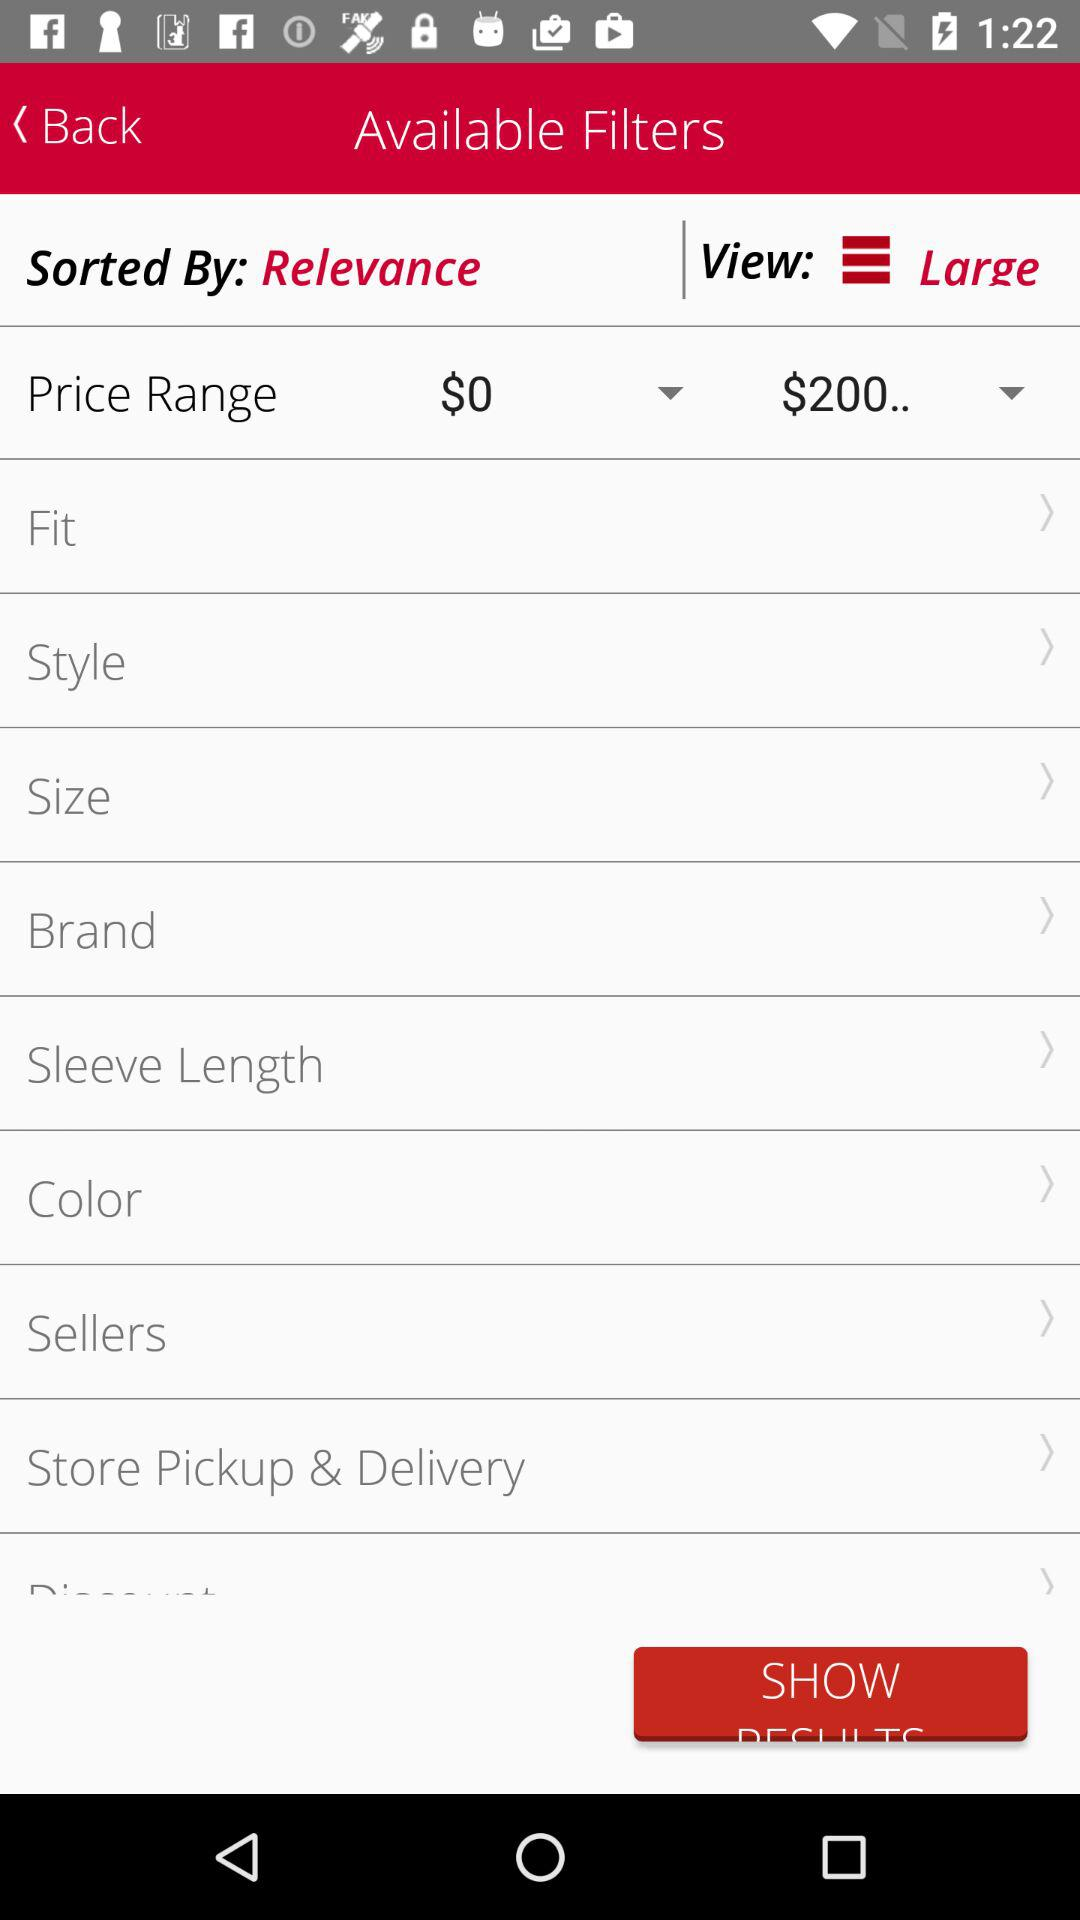How many more filters are there in the price range section than in the brand section?
Answer the question using a single word or phrase. 2 